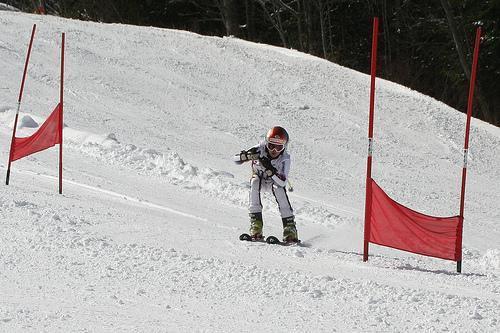How many people are in the picture?
Give a very brief answer. 1. 